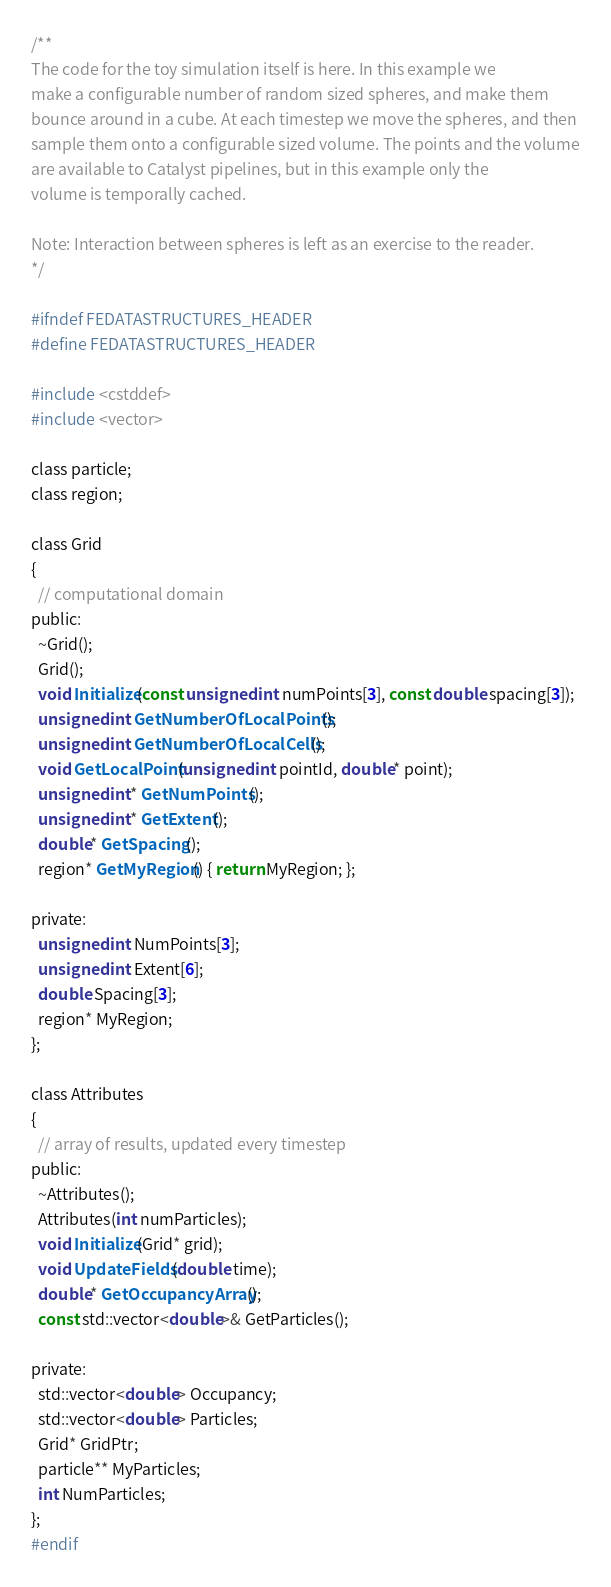Convert code to text. <code><loc_0><loc_0><loc_500><loc_500><_C_>/**
The code for the toy simulation itself is here. In this example we
make a configurable number of random sized spheres, and make them
bounce around in a cube. At each timestep we move the spheres, and then
sample them onto a configurable sized volume. The points and the volume
are available to Catalyst pipelines, but in this example only the
volume is temporally cached.

Note: Interaction between spheres is left as an exercise to the reader.
*/

#ifndef FEDATASTRUCTURES_HEADER
#define FEDATASTRUCTURES_HEADER

#include <cstddef>
#include <vector>

class particle;
class region;

class Grid
{
  // computational domain
public:
  ~Grid();
  Grid();
  void Initialize(const unsigned int numPoints[3], const double spacing[3]);
  unsigned int GetNumberOfLocalPoints();
  unsigned int GetNumberOfLocalCells();
  void GetLocalPoint(unsigned int pointId, double* point);
  unsigned int* GetNumPoints();
  unsigned int* GetExtent();
  double* GetSpacing();
  region* GetMyRegion() { return MyRegion; };

private:
  unsigned int NumPoints[3];
  unsigned int Extent[6];
  double Spacing[3];
  region* MyRegion;
};

class Attributes
{
  // array of results, updated every timestep
public:
  ~Attributes();
  Attributes(int numParticles);
  void Initialize(Grid* grid);
  void UpdateFields(double time);
  double* GetOccupancyArray();
  const std::vector<double>& GetParticles();

private:
  std::vector<double> Occupancy;
  std::vector<double> Particles;
  Grid* GridPtr;
  particle** MyParticles;
  int NumParticles;
};
#endif
</code> 